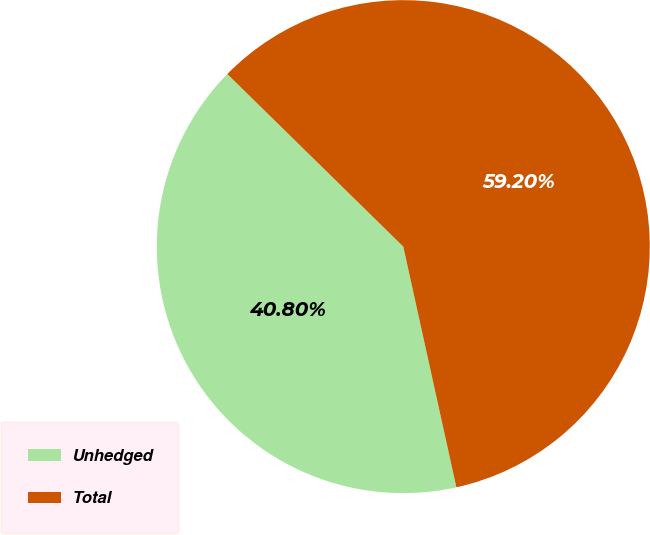<chart> <loc_0><loc_0><loc_500><loc_500><pie_chart><fcel>Unhedged<fcel>Total<nl><fcel>40.8%<fcel>59.2%<nl></chart> 